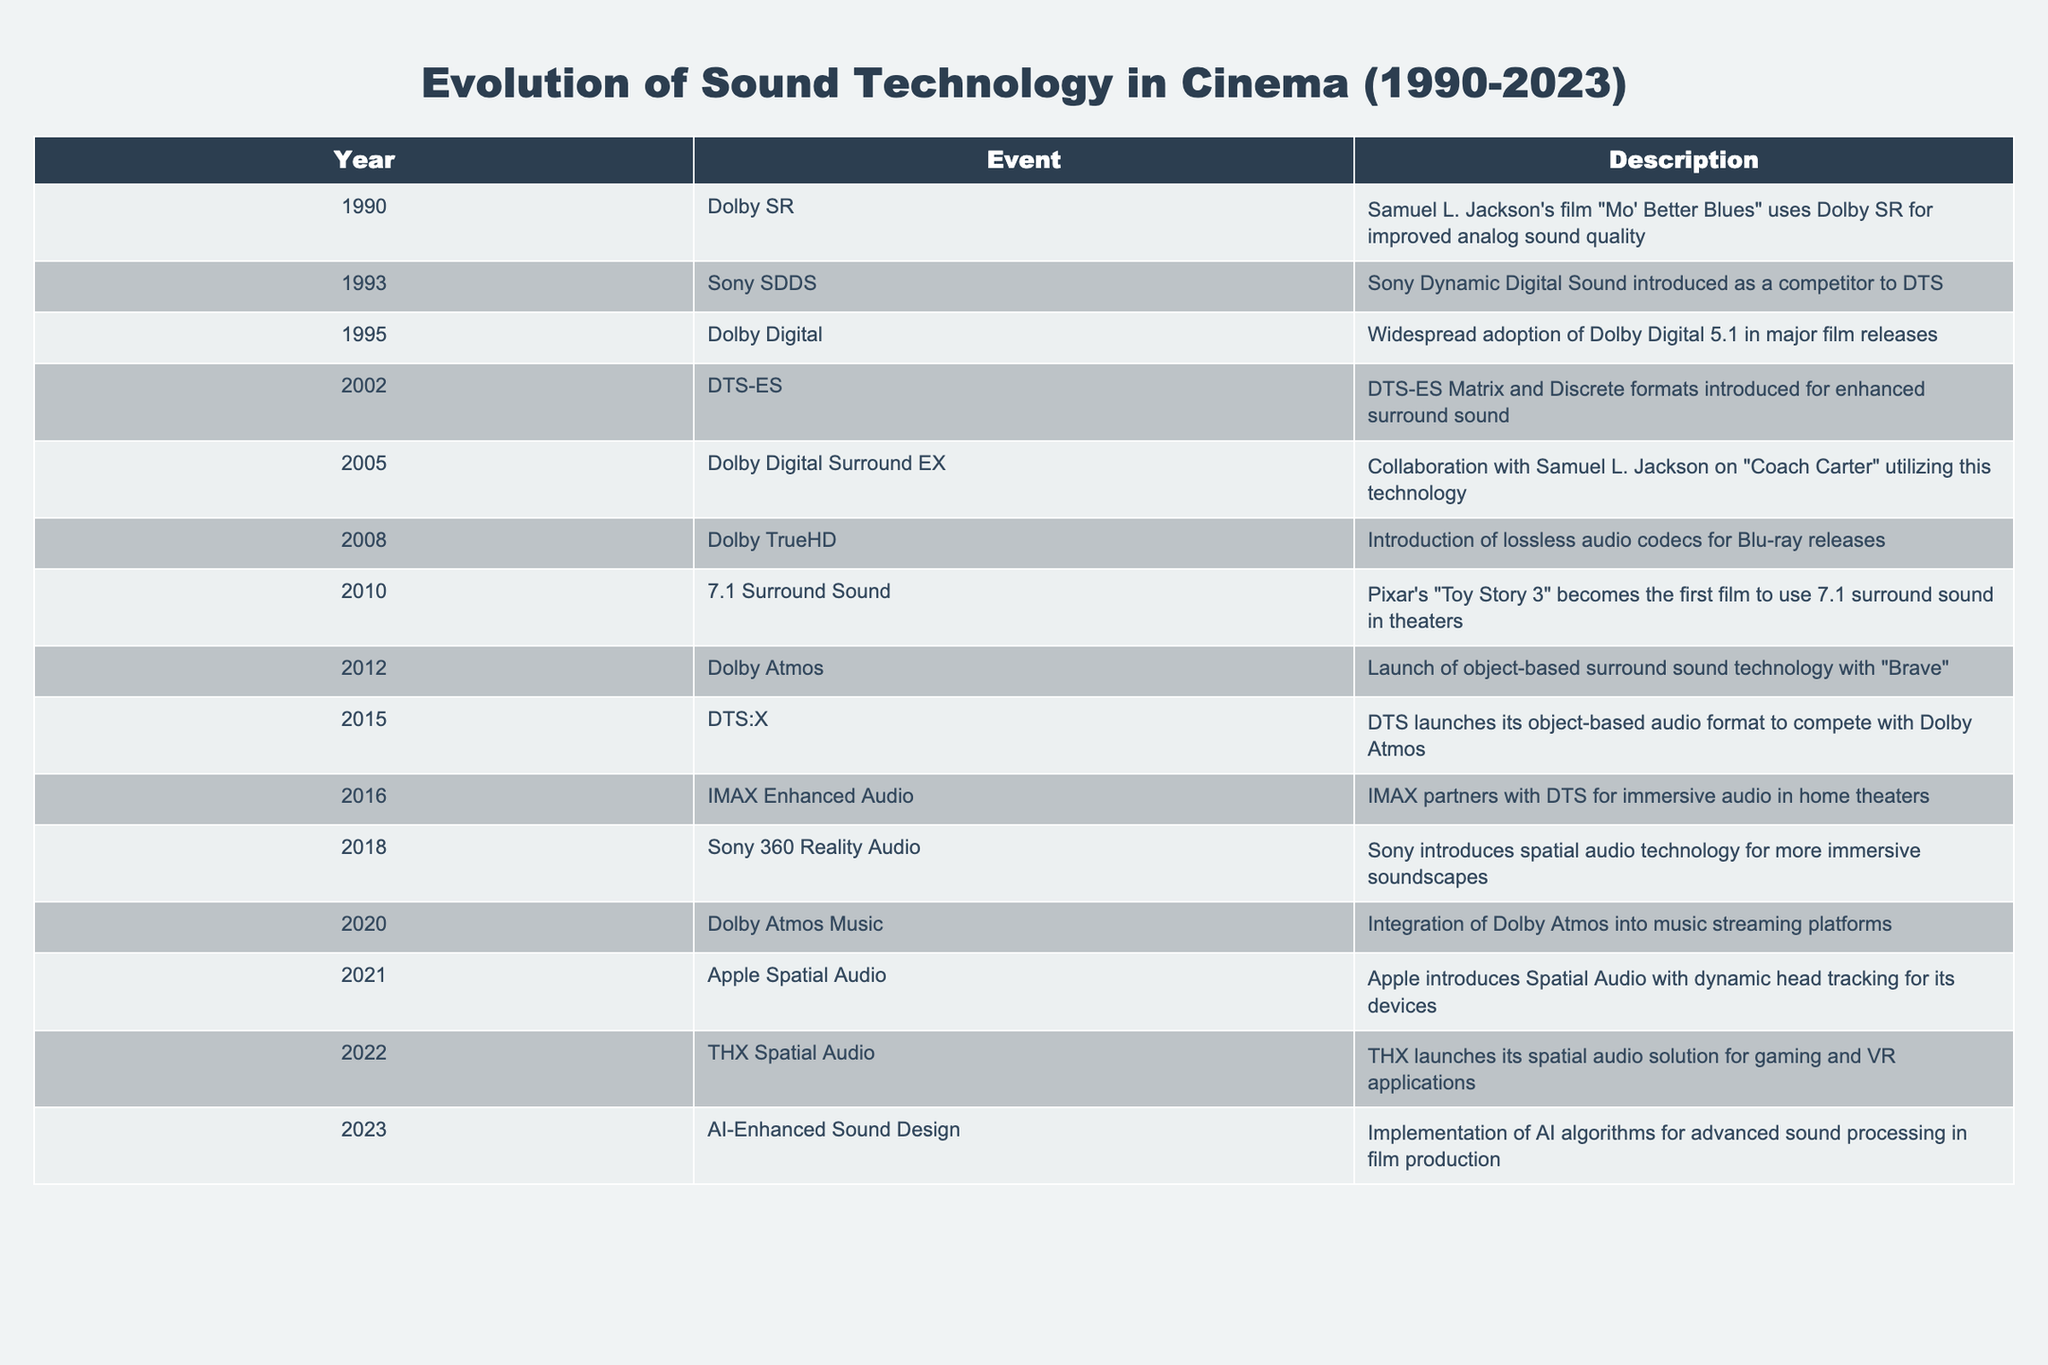What year did Dolby Digital become widely adopted? The table indicates that Dolby Digital was adopted widely in the year 1995.
Answer: 1995 What technologies were introduced in 2002? According to the table, the technology introduced in 2002 was DTS-ES, which includes both Matrix and Discrete formats for enhanced surround sound.
Answer: DTS-ES Did Samuel L. Jackson collaborate on any film utilizing Dolby Digital Surround EX? Yes, the table shows that Samuel L. Jackson collaborated on "Coach Carter," which utilized Dolby Digital Surround EX in 2005.
Answer: Yes Which technology was the first to use 7.1 surround sound? The table lists Pixar's "Toy Story 3," which is marked as the first film to use 7.1 surround sound in theaters, introduced in 2010.
Answer: Toy Story 3 What is the difference in years between the introduction of Dolby Atmos and DTS:X? Dolby Atmos was introduced in 2012 and DTS:X was introduced in 2015, so the difference is 3 years (2015 - 2012 = 3).
Answer: 3 years How many new audio technologies were introduced between 2010 and 2020? From the table, the audio technologies introduced in that time frame are 7.1 Surround Sound (2010), Dolby Atmos (2012), DTS:X (2015), and Dolby Atmos Music (2020). This totals 4 new technologies.
Answer: 4 Was AI-enhanced sound design the last technology mentioned in the table? Yes, the table indicates that AI-Enhanced Sound Design was introduced in 2023, and it is the last entry in the timeline.
Answer: Yes What is the trend of sound technology advancement over the years listed in the table? The data shows a clear trend of continuous innovation in sound technology, with a consistent introduction of new formats and methods leading to increasingly immersive audio experiences. This suggests a focus on enhancing sound depth, spatial audio, and integration with other media platforms over the years.
Answer: Continuous innovation Which audio technology targets gaming and VR applications? According to the table, THX Spatial Audio, introduced in 2022, targets gaming and VR applications.
Answer: THX Spatial Audio 